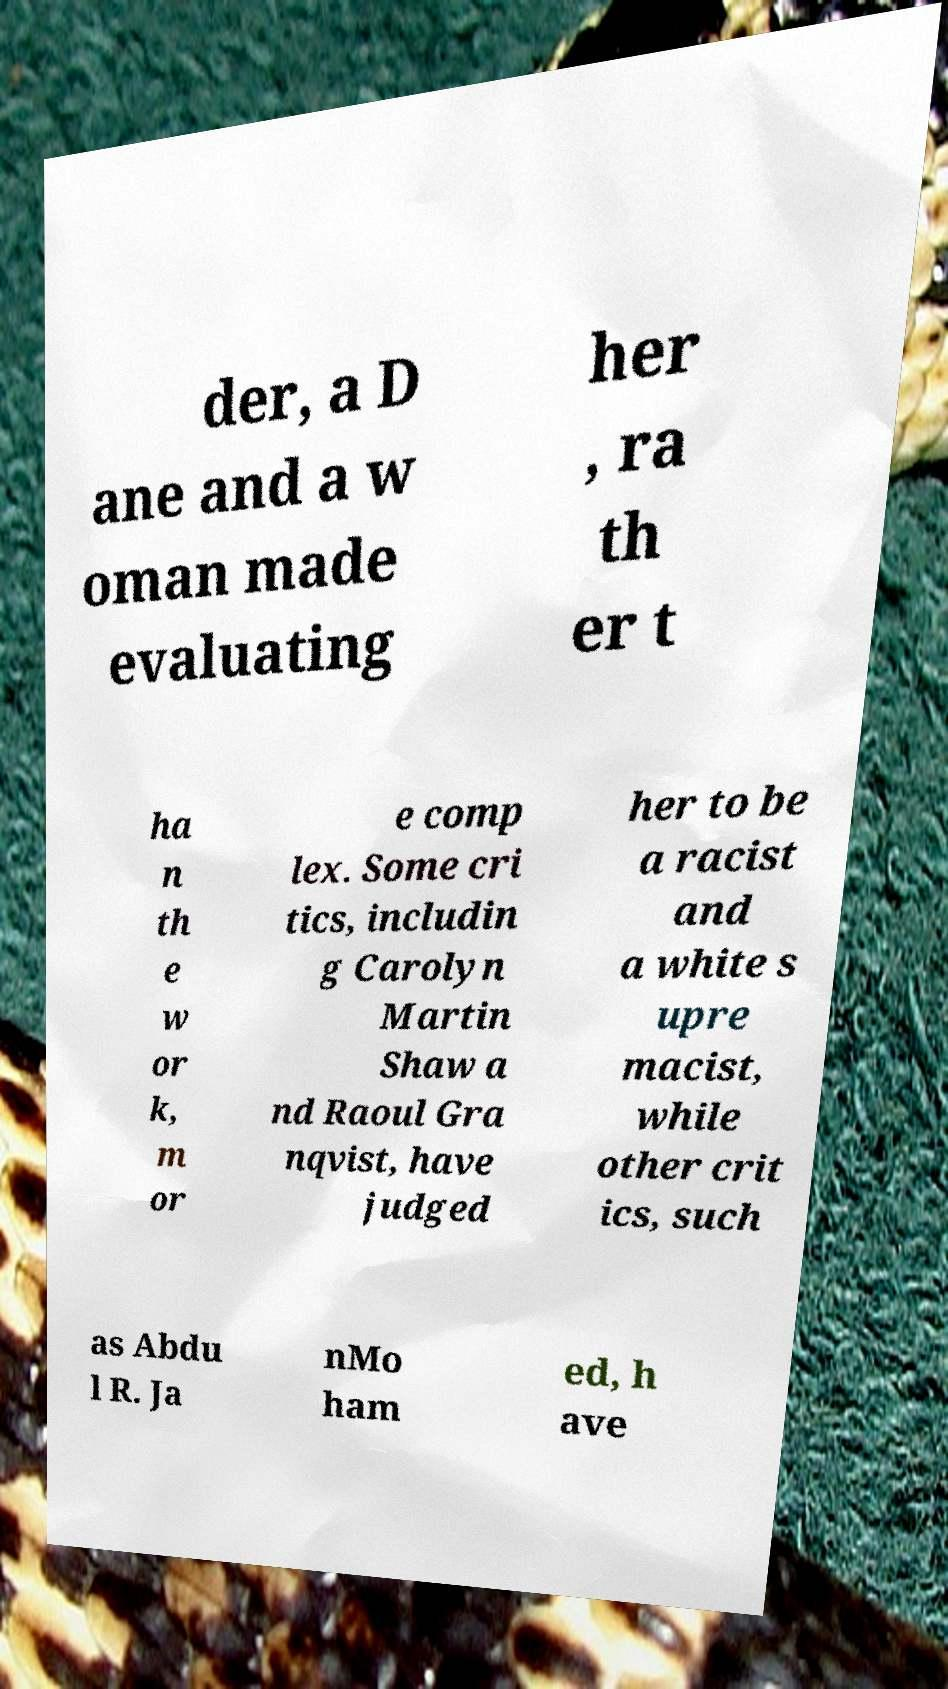Can you accurately transcribe the text from the provided image for me? der, a D ane and a w oman made evaluating her , ra th er t ha n th e w or k, m or e comp lex. Some cri tics, includin g Carolyn Martin Shaw a nd Raoul Gra nqvist, have judged her to be a racist and a white s upre macist, while other crit ics, such as Abdu l R. Ja nMo ham ed, h ave 